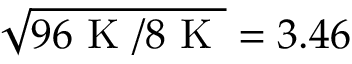Convert formula to latex. <formula><loc_0><loc_0><loc_500><loc_500>\sqrt { 9 6 K / 8 K } = 3 . 4 6</formula> 